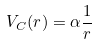Convert formula to latex. <formula><loc_0><loc_0><loc_500><loc_500>V _ { C } ( r ) = \alpha \frac { 1 } { r }</formula> 